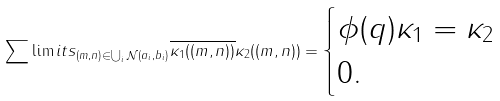<formula> <loc_0><loc_0><loc_500><loc_500>\sum \lim i t s _ { ( m , n ) \in \bigcup _ { i } \mathcal { N } ( a _ { i } , b _ { i } ) } \overline { \kappa _ { 1 } ( ( m , n ) ) } \kappa _ { 2 } ( ( m , n ) ) = \begin{cases} \phi ( q ) \kappa _ { 1 } = \kappa _ { 2 } \\ 0 . \end{cases}</formula> 